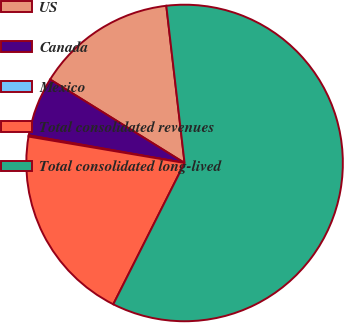Convert chart to OTSL. <chart><loc_0><loc_0><loc_500><loc_500><pie_chart><fcel>US<fcel>Canada<fcel>Mexico<fcel>Total consolidated revenues<fcel>Total consolidated long-lived<nl><fcel>14.31%<fcel>6.05%<fcel>0.13%<fcel>20.23%<fcel>59.28%<nl></chart> 